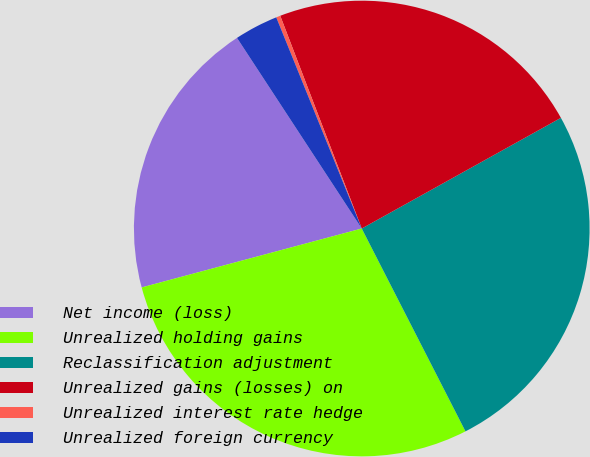<chart> <loc_0><loc_0><loc_500><loc_500><pie_chart><fcel>Net income (loss)<fcel>Unrealized holding gains<fcel>Reclassification adjustment<fcel>Unrealized gains (losses) on<fcel>Unrealized interest rate hedge<fcel>Unrealized foreign currency<nl><fcel>19.94%<fcel>28.36%<fcel>25.55%<fcel>22.75%<fcel>0.3%<fcel>3.1%<nl></chart> 